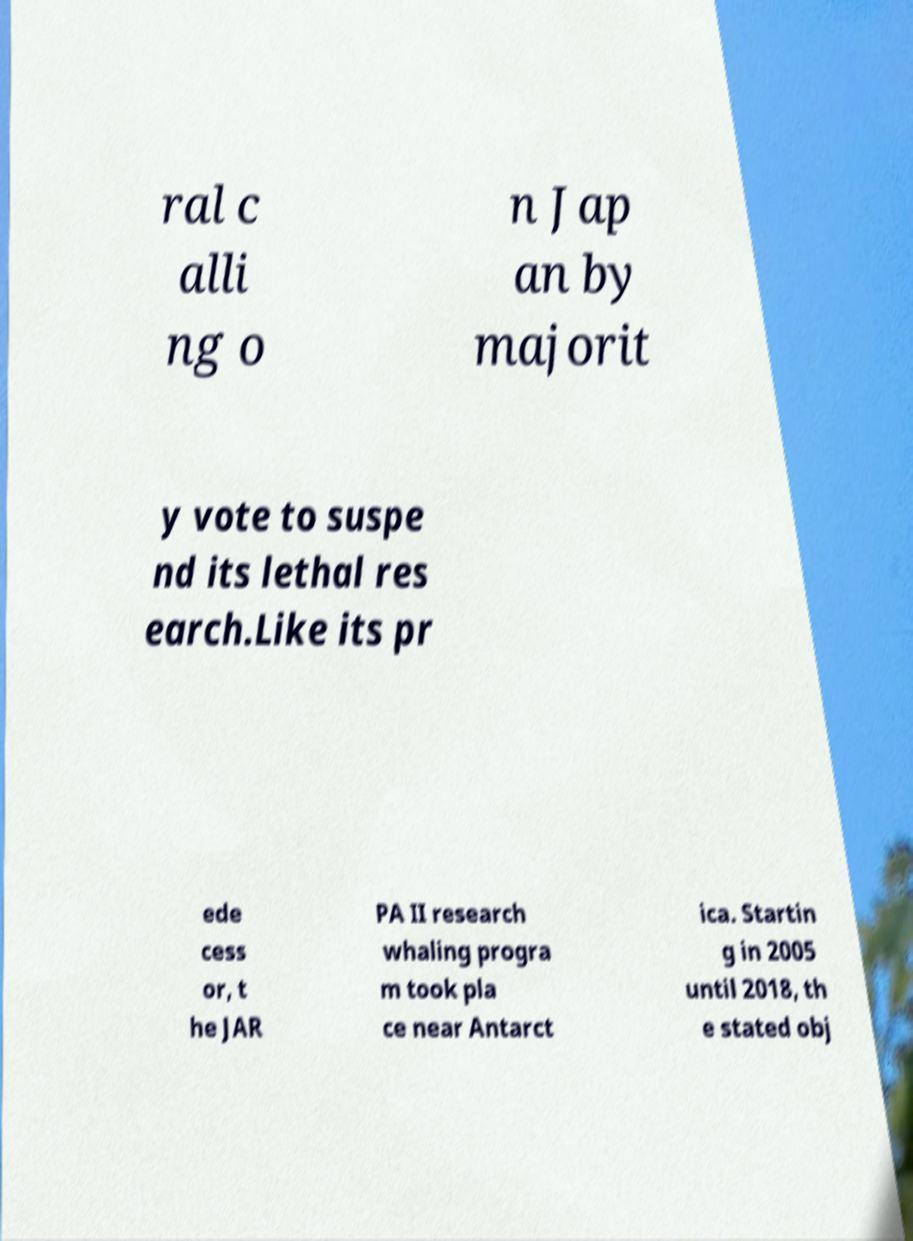Please identify and transcribe the text found in this image. ral c alli ng o n Jap an by majorit y vote to suspe nd its lethal res earch.Like its pr ede cess or, t he JAR PA II research whaling progra m took pla ce near Antarct ica. Startin g in 2005 until 2018, th e stated obj 